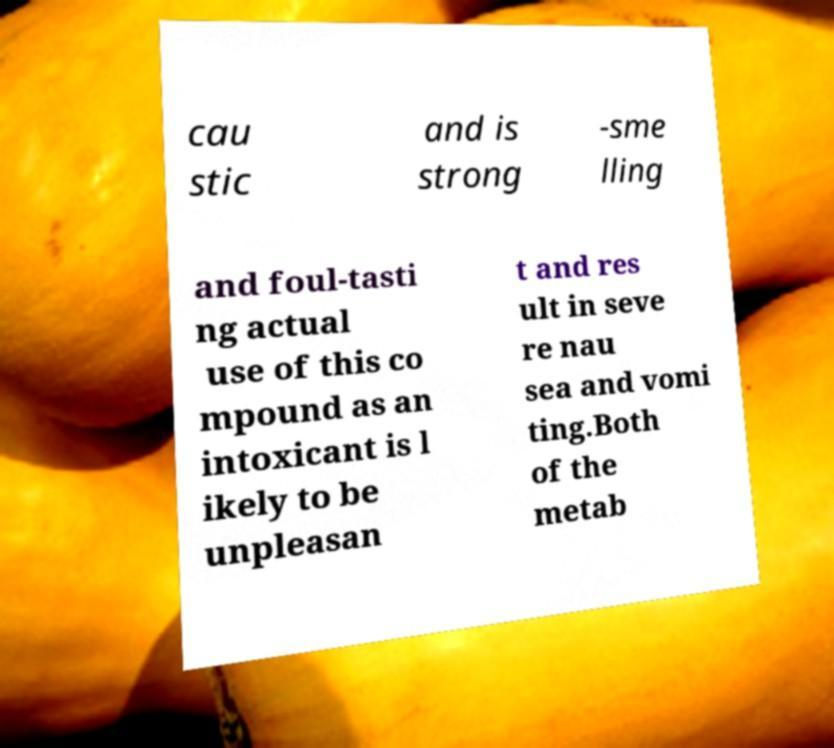There's text embedded in this image that I need extracted. Can you transcribe it verbatim? cau stic and is strong -sme lling and foul-tasti ng actual use of this co mpound as an intoxicant is l ikely to be unpleasan t and res ult in seve re nau sea and vomi ting.Both of the metab 